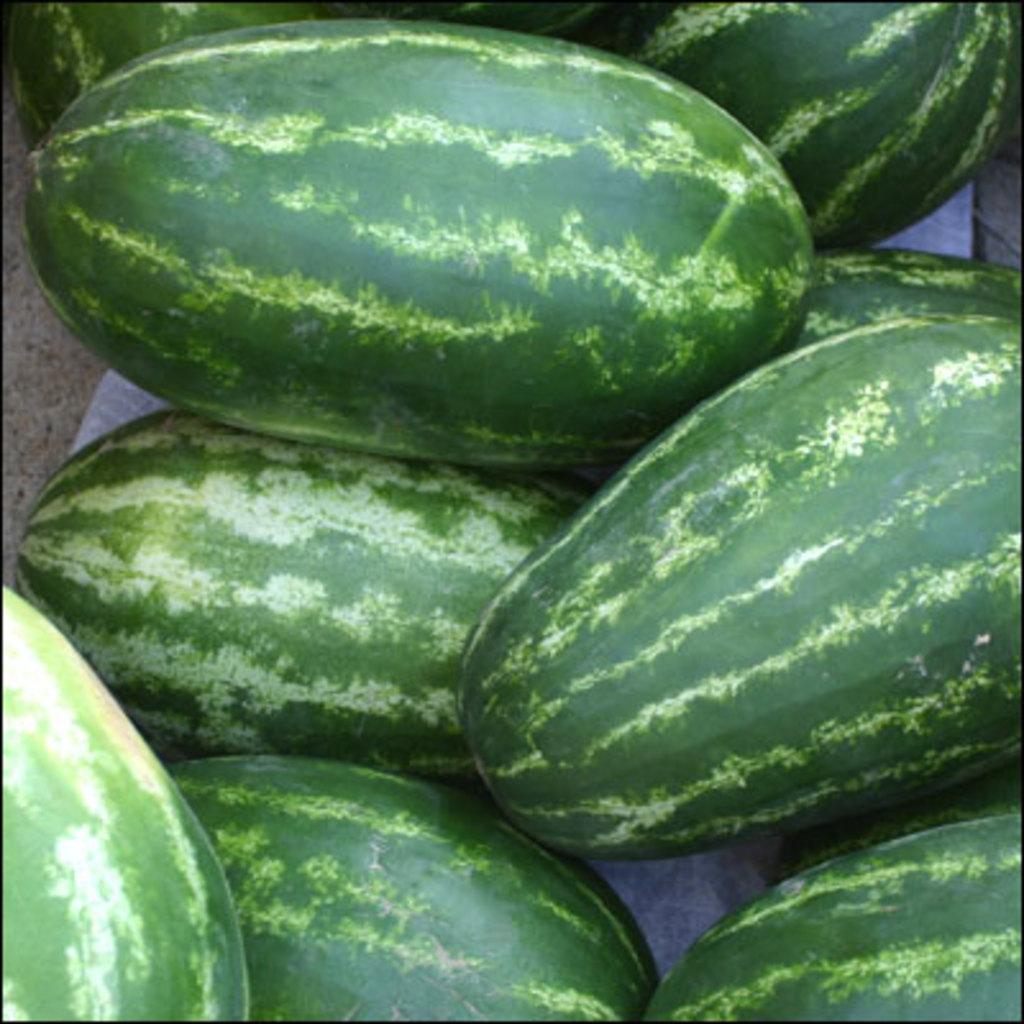What type of fruit is present in the image? There are watermelons in the image. What shape is the watermelon in the image? The shape of the watermelon cannot be determined from the image alone, as it is not shown in a way that allows us to discern its shape. 